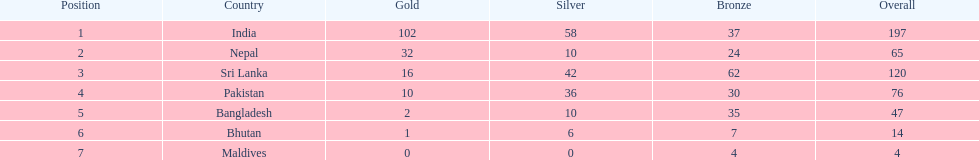How many countries have one more than 10 gold medals? 3. 